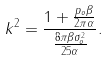<formula> <loc_0><loc_0><loc_500><loc_500>k ^ { 2 } = \frac { 1 + \frac { p _ { o } \beta } { 2 \pi \alpha } } { \frac { 8 \pi \beta \sigma _ { o } ^ { 2 } } { 2 5 \alpha } } .</formula> 